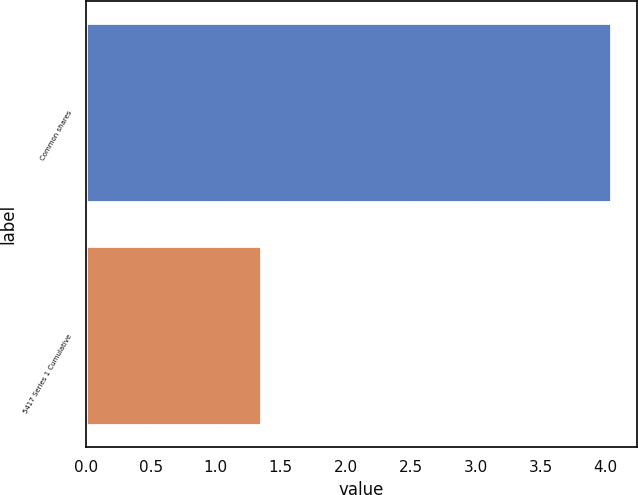Convert chart. <chart><loc_0><loc_0><loc_500><loc_500><bar_chart><fcel>Common shares<fcel>5417 Series 1 Cumulative<nl><fcel>4.04<fcel>1.35<nl></chart> 